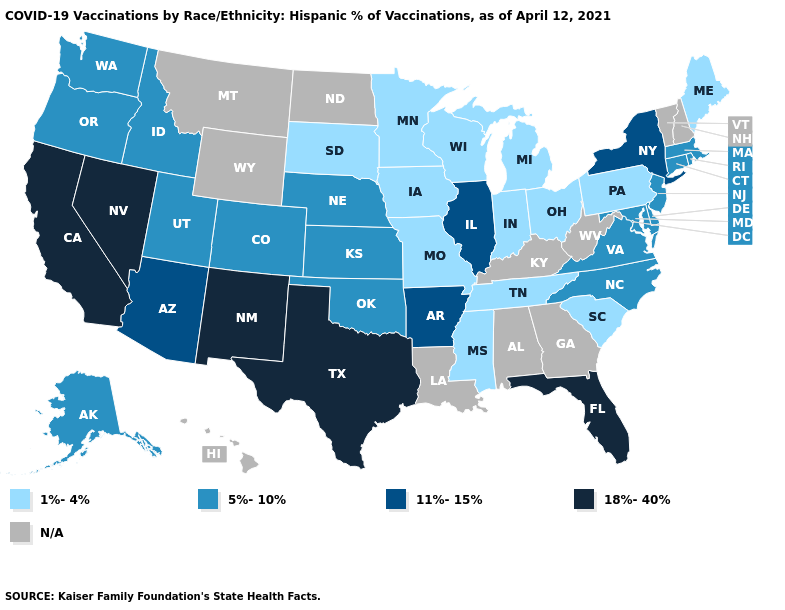What is the lowest value in the West?
Give a very brief answer. 5%-10%. Is the legend a continuous bar?
Quick response, please. No. Among the states that border Kansas , which have the lowest value?
Write a very short answer. Missouri. What is the lowest value in states that border Alabama?
Answer briefly. 1%-4%. What is the lowest value in the Northeast?
Write a very short answer. 1%-4%. What is the value of Massachusetts?
Write a very short answer. 5%-10%. How many symbols are there in the legend?
Keep it brief. 5. What is the lowest value in the USA?
Be succinct. 1%-4%. What is the lowest value in the USA?
Quick response, please. 1%-4%. What is the value of Arizona?
Write a very short answer. 11%-15%. What is the value of Kansas?
Short answer required. 5%-10%. How many symbols are there in the legend?
Keep it brief. 5. 